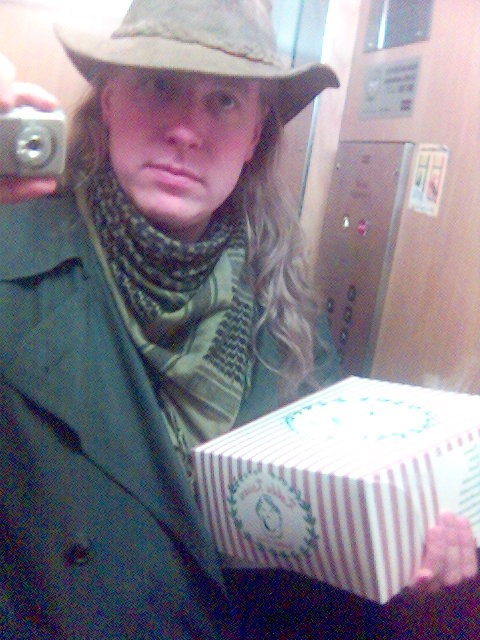Describe the objects in this image and their specific colors. I can see people in lavender, gray, blue, black, and navy tones in this image. 